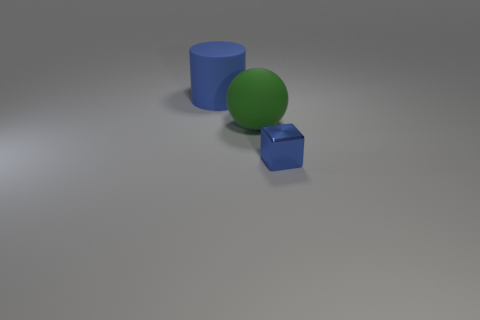There is a tiny cube that is the same color as the large cylinder; what is it made of?
Ensure brevity in your answer.  Metal. What is the size of the shiny block that is the same color as the cylinder?
Your answer should be very brief. Small. Is the big cylinder the same color as the shiny cube?
Your response must be concise. Yes. There is a small thing that is the same color as the cylinder; what is its shape?
Offer a terse response. Cube. The sphere that is the same size as the cylinder is what color?
Your answer should be compact. Green. Are there more big objects on the left side of the tiny blue block than big purple rubber objects?
Offer a terse response. Yes. What material is the object that is both behind the blue cube and on the right side of the big blue rubber cylinder?
Make the answer very short. Rubber. There is a large thing that is behind the matte sphere; does it have the same color as the object right of the rubber ball?
Give a very brief answer. Yes. What number of other things are there of the same size as the metallic thing?
Make the answer very short. 0. Is there a blue thing that is in front of the blue object behind the tiny metallic thing that is right of the green matte thing?
Keep it short and to the point. Yes. 